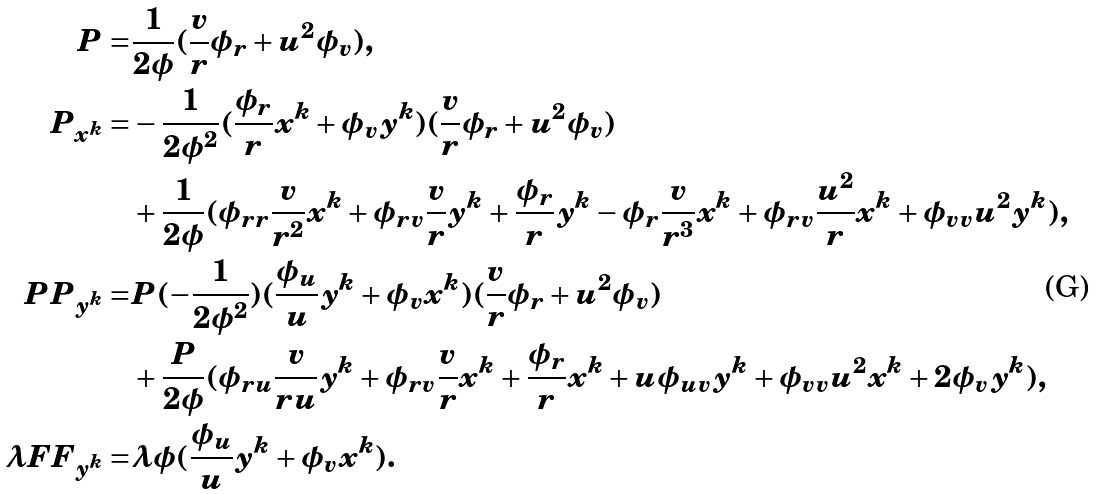<formula> <loc_0><loc_0><loc_500><loc_500>P = & \frac { 1 } { 2 \phi } ( \frac { v } { r } \phi _ { r } + u ^ { 2 } \phi _ { v } ) , \\ P _ { x ^ { k } } = & - \frac { 1 } { 2 \phi ^ { 2 } } ( \frac { \phi _ { r } } { r } x ^ { k } + \phi _ { v } y ^ { k } ) ( \frac { v } { r } \phi _ { r } + u ^ { 2 } \phi _ { v } ) \\ & + \frac { 1 } { 2 \phi } ( \phi _ { r r } \frac { v } { r ^ { 2 } } x ^ { k } + \phi _ { r v } \frac { v } { r } y ^ { k } + \frac { \phi _ { r } } { r } y ^ { k } - \phi _ { r } \frac { v } { r ^ { 3 } } x ^ { k } + \phi _ { r v } \frac { u ^ { 2 } } { r } x ^ { k } + \phi _ { v v } u ^ { 2 } y ^ { k } ) , \\ P P _ { y ^ { k } } = & P ( - \frac { 1 } { 2 \phi ^ { 2 } } ) ( \frac { \phi _ { u } } { u } y ^ { k } + \phi _ { v } x ^ { k } ) ( \frac { v } { r } \phi _ { r } + u ^ { 2 } \phi _ { v } ) \\ & + \frac { P } { 2 \phi } ( \phi _ { r u } \frac { v } { r u } y ^ { k } + \phi _ { r v } \frac { v } { r } x ^ { k } + \frac { \phi _ { r } } { r } x ^ { k } + u \phi _ { u v } y ^ { k } + \phi _ { v v } u ^ { 2 } x ^ { k } + 2 \phi _ { v } y ^ { k } ) , \\ \lambda F F _ { y ^ { k } } = & \lambda \phi ( \frac { \phi _ { u } } { u } y ^ { k } + \phi _ { v } x ^ { k } ) .</formula> 